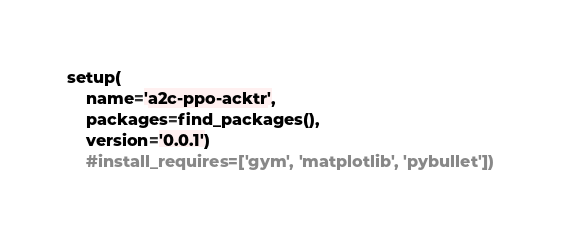<code> <loc_0><loc_0><loc_500><loc_500><_Python_>
setup(
    name='a2c-ppo-acktr',
    packages=find_packages(),
    version='0.0.1')
    #install_requires=['gym', 'matplotlib', 'pybullet'])
</code> 